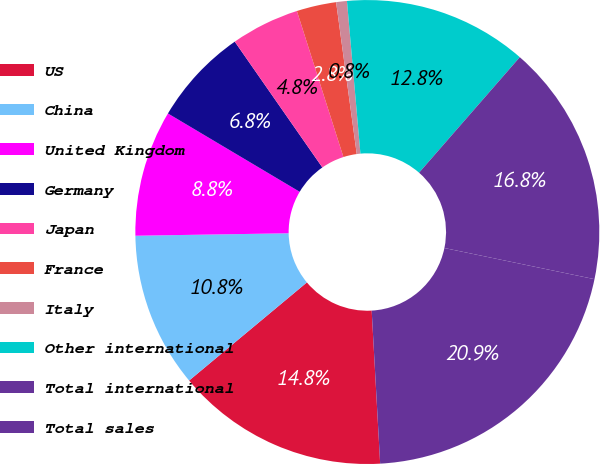Convert chart. <chart><loc_0><loc_0><loc_500><loc_500><pie_chart><fcel>US<fcel>China<fcel>United Kingdom<fcel>Germany<fcel>Japan<fcel>France<fcel>Italy<fcel>Other international<fcel>Total international<fcel>Total sales<nl><fcel>14.82%<fcel>10.8%<fcel>8.79%<fcel>6.78%<fcel>4.77%<fcel>2.76%<fcel>0.75%<fcel>12.81%<fcel>16.84%<fcel>20.86%<nl></chart> 